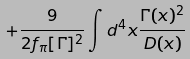<formula> <loc_0><loc_0><loc_500><loc_500>\quad \ \ + \frac { 9 } { 2 f _ { \pi } [ \Gamma ] ^ { 2 } } \int d ^ { 4 } x \frac { \Gamma ( x ) ^ { 2 } } { D ( x ) }</formula> 